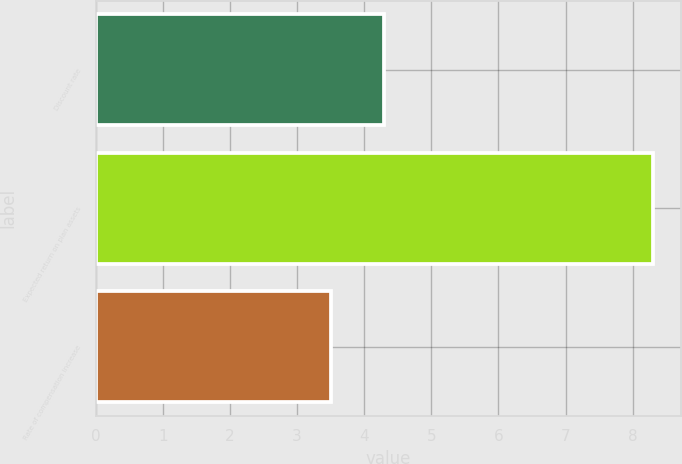Convert chart to OTSL. <chart><loc_0><loc_0><loc_500><loc_500><bar_chart><fcel>Discount rate<fcel>Expected return on plan assets<fcel>Rate of compensation increase<nl><fcel>4.3<fcel>8.3<fcel>3.5<nl></chart> 